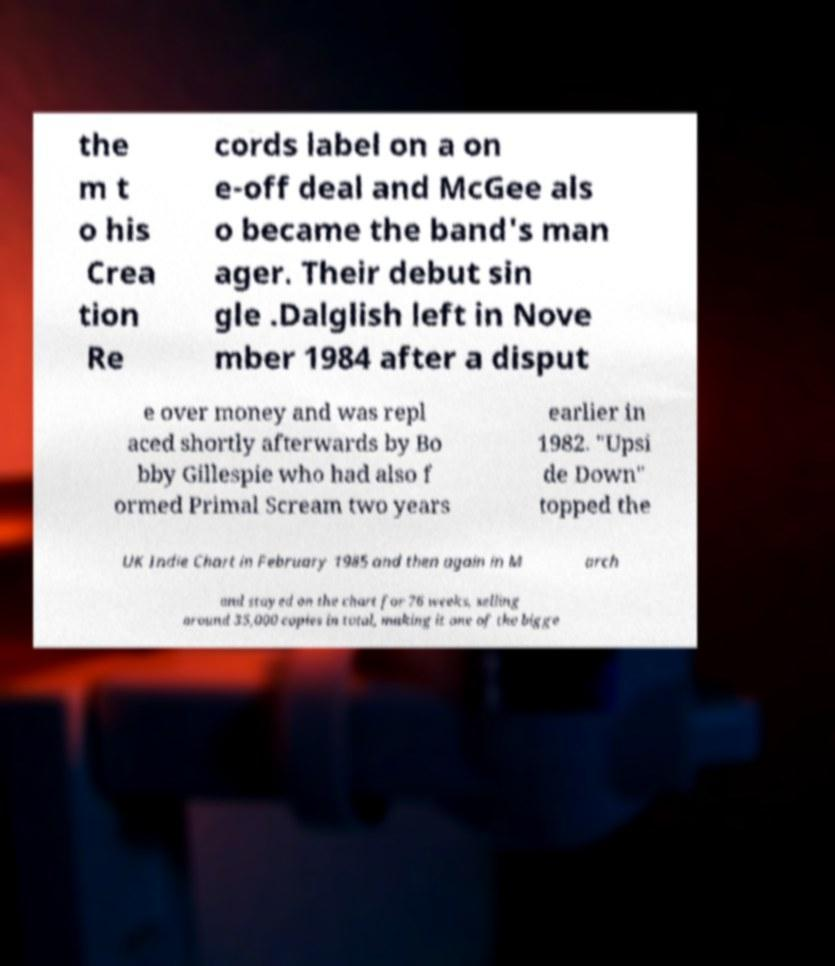I need the written content from this picture converted into text. Can you do that? the m t o his Crea tion Re cords label on a on e-off deal and McGee als o became the band's man ager. Their debut sin gle .Dalglish left in Nove mber 1984 after a disput e over money and was repl aced shortly afterwards by Bo bby Gillespie who had also f ormed Primal Scream two years earlier in 1982. "Upsi de Down" topped the UK Indie Chart in February 1985 and then again in M arch and stayed on the chart for 76 weeks, selling around 35,000 copies in total, making it one of the bigge 